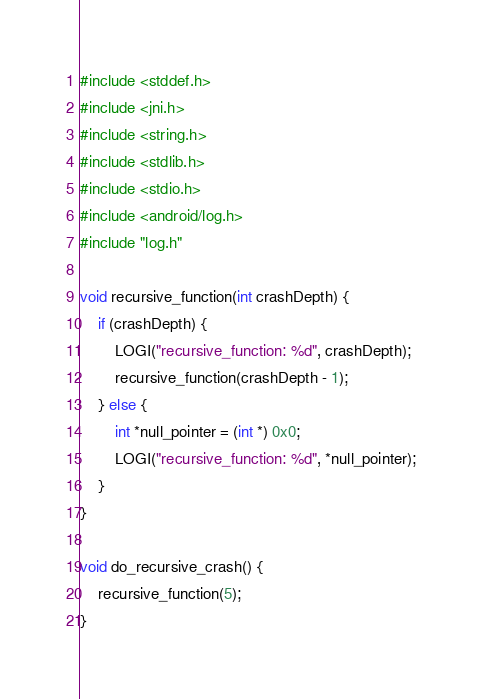<code> <loc_0><loc_0><loc_500><loc_500><_C_>#include <stddef.h>
#include <jni.h>
#include <string.h>
#include <stdlib.h>
#include <stdio.h>
#include <android/log.h>
#include "log.h"

void recursive_function(int crashDepth) {
	if (crashDepth) {
		LOGI("recursive_function: %d", crashDepth);
		recursive_function(crashDepth - 1);
	} else {
		int *null_pointer = (int *) 0x0;
		LOGI("recursive_function: %d", *null_pointer);
	}
}

void do_recursive_crash() {
	recursive_function(5);
}
</code> 